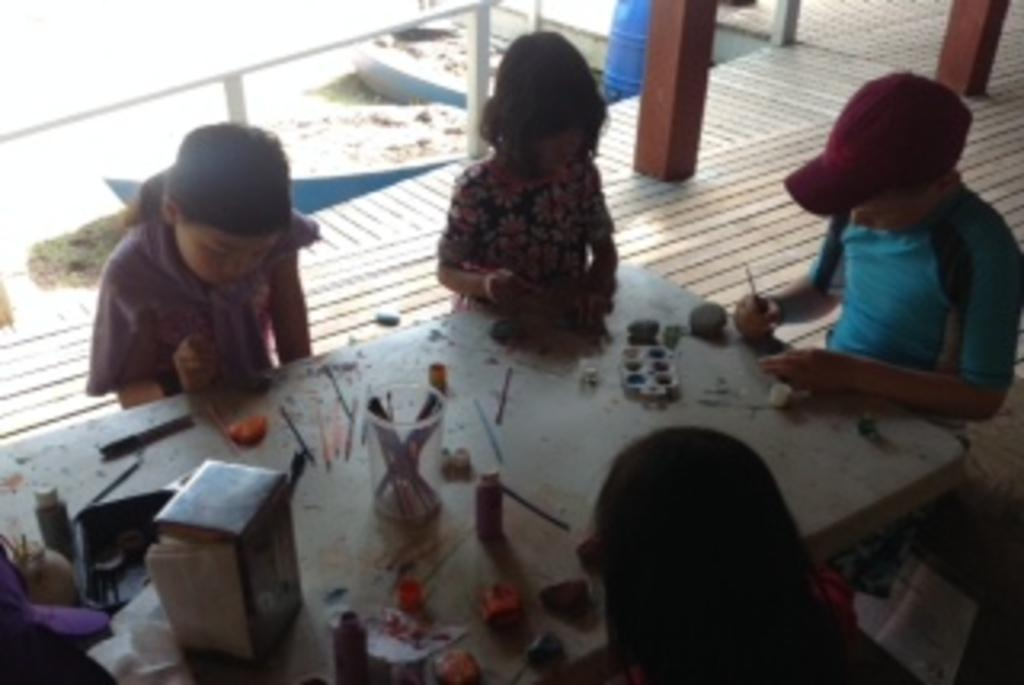How many people are present in the image? There are four people seated in the image. What are the people doing in the image? The people are playing with watercolors on a table. What else can be seen on the table? There is a glass and pens on the table. What is the girl's voice like in the image? There is no girl mentioned in the image, and therefore no information about her voice is available. 